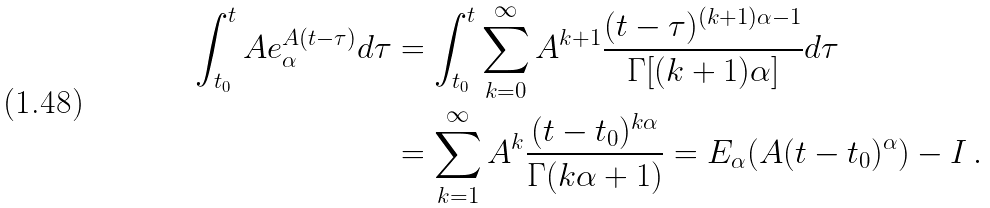Convert formula to latex. <formula><loc_0><loc_0><loc_500><loc_500>\int _ { t _ { 0 } } ^ { t } A e _ { \alpha } ^ { A ( t - \tau ) } d \tau & = \int _ { t _ { 0 } } ^ { t } \sum _ { k = 0 } ^ { \infty } A ^ { k + 1 } \frac { ( t - \tau ) ^ { ( k + 1 ) \alpha - 1 } } { \Gamma [ ( k + 1 ) \alpha ] } d \tau \\ & = \sum _ { k = 1 } ^ { \infty } A ^ { k } \frac { ( t - t _ { 0 } ) ^ { k \alpha } } { \Gamma ( k \alpha + 1 ) } = E _ { \alpha } ( A ( t - t _ { 0 } ) ^ { \alpha } ) - I \, .</formula> 